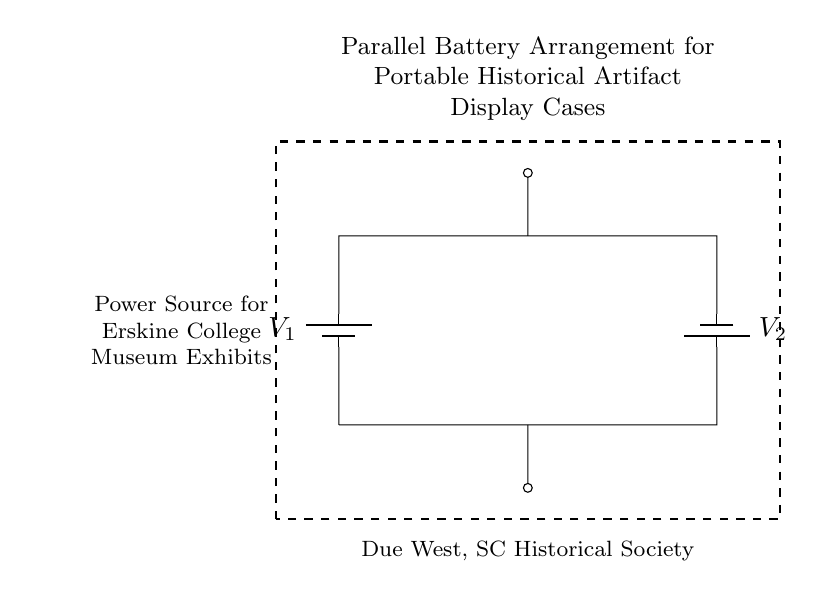What type of battery arrangement is depicted? The circuit diagram shows a parallel battery arrangement, where multiple batteries are connected alongside each other, providing a combined voltage.
Answer: parallel How many batteries are present in the circuit? The circuit diagram clearly depicts two batteries connected in parallel. Count the symbols to reach this conclusion.
Answer: 2 What is the role of the dashed rectangle in the circuit? The dashed rectangle is used to represent the enclosure or the display case for the portable historical artifacts, indicating the area that the circuit is powering.
Answer: display case What is the potential difference across the batteries? In a parallel connection, the voltage across each battery remains the same. The voltage of the batteries has not been specified individually, but it maintains its individual characteristics in this arrangement.
Answer: V1, V2 What function do the batteries serve in this arrangement? The batteries provide electrical power to the display cases, which are aimed at showcasing historical artifacts. This is indicated by the description in the circuit.
Answer: power source Why is a parallel battery configuration preferred for display cases? A parallel configuration allows for increased current capacity while keeping the voltage constant. This is beneficial in applications like display cases, where consistent power is needed for longer durations.
Answer: increased current capacity What does the label "Due West, SC Historical Society" indicate? The label identifies the ownership or the institution that is associated with the power source setup, likely implying the historical context and purpose for which the arrangement is used.
Answer: ownership/association 